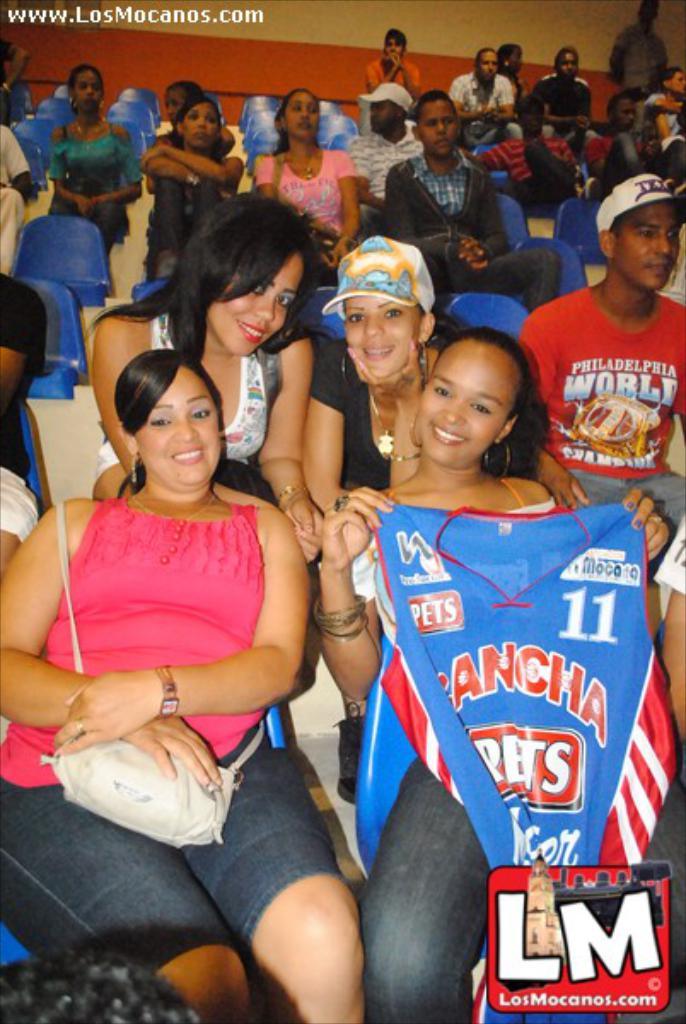What number is the blue jersey?
Provide a succinct answer. 11. What website is the image from?
Your answer should be compact. Losmocanos.com. 